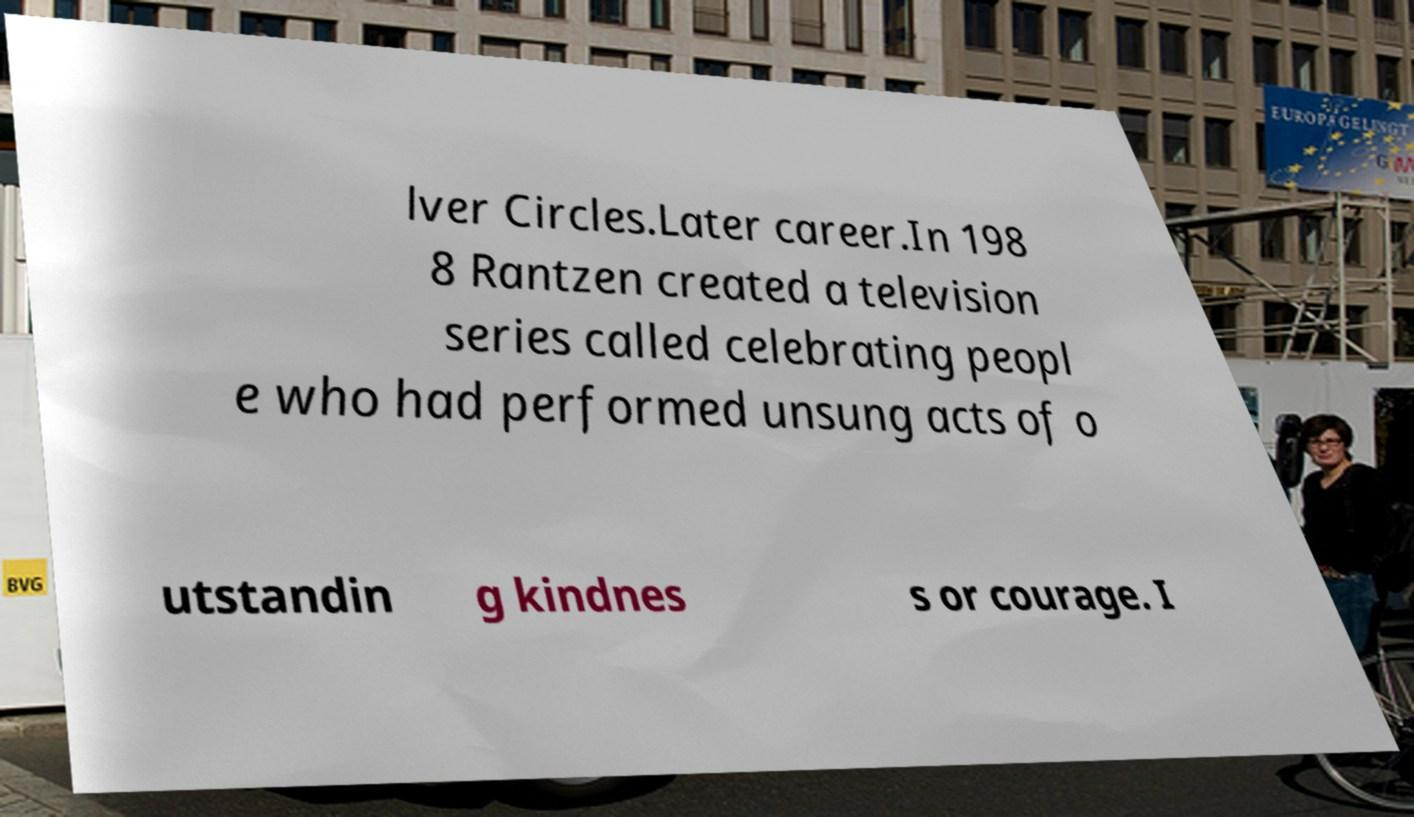Please read and relay the text visible in this image. What does it say? lver Circles.Later career.In 198 8 Rantzen created a television series called celebrating peopl e who had performed unsung acts of o utstandin g kindnes s or courage. I 